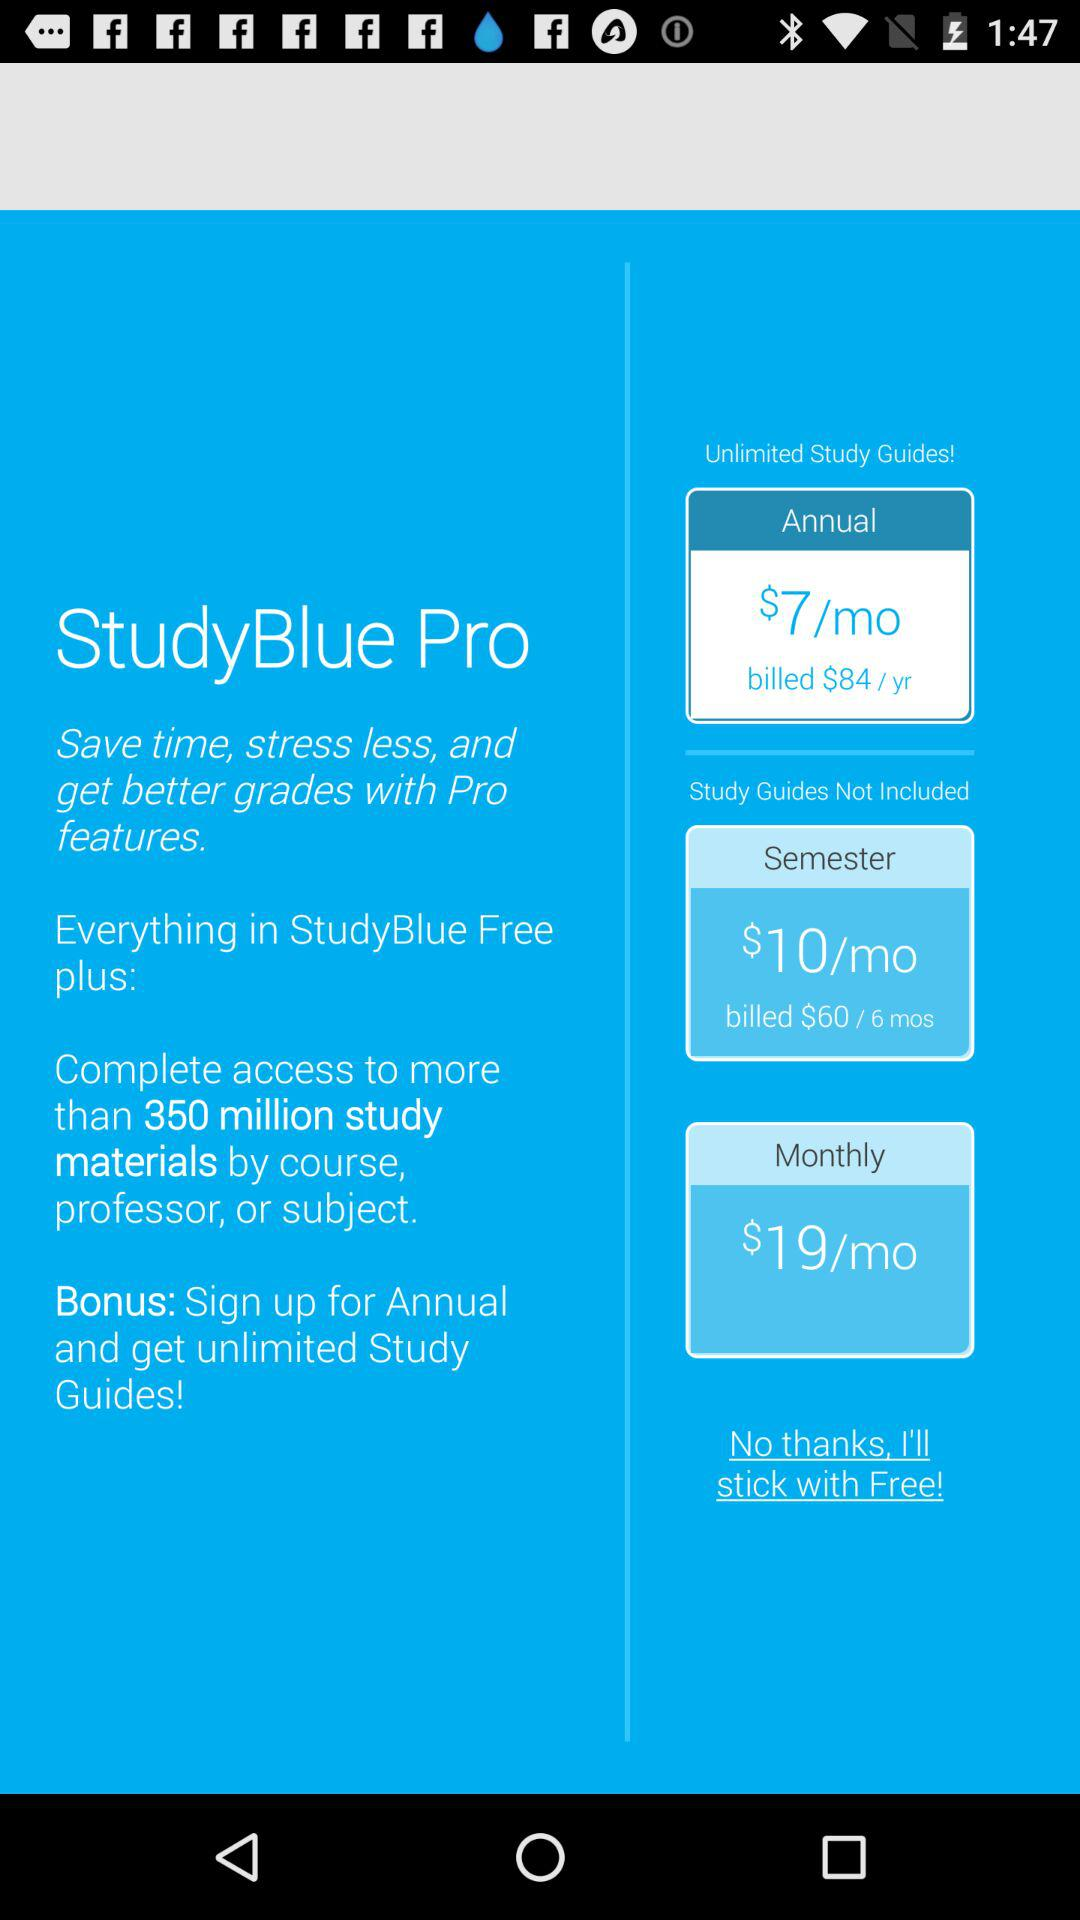What is the annual cost? The annual cost is $84/yr. 